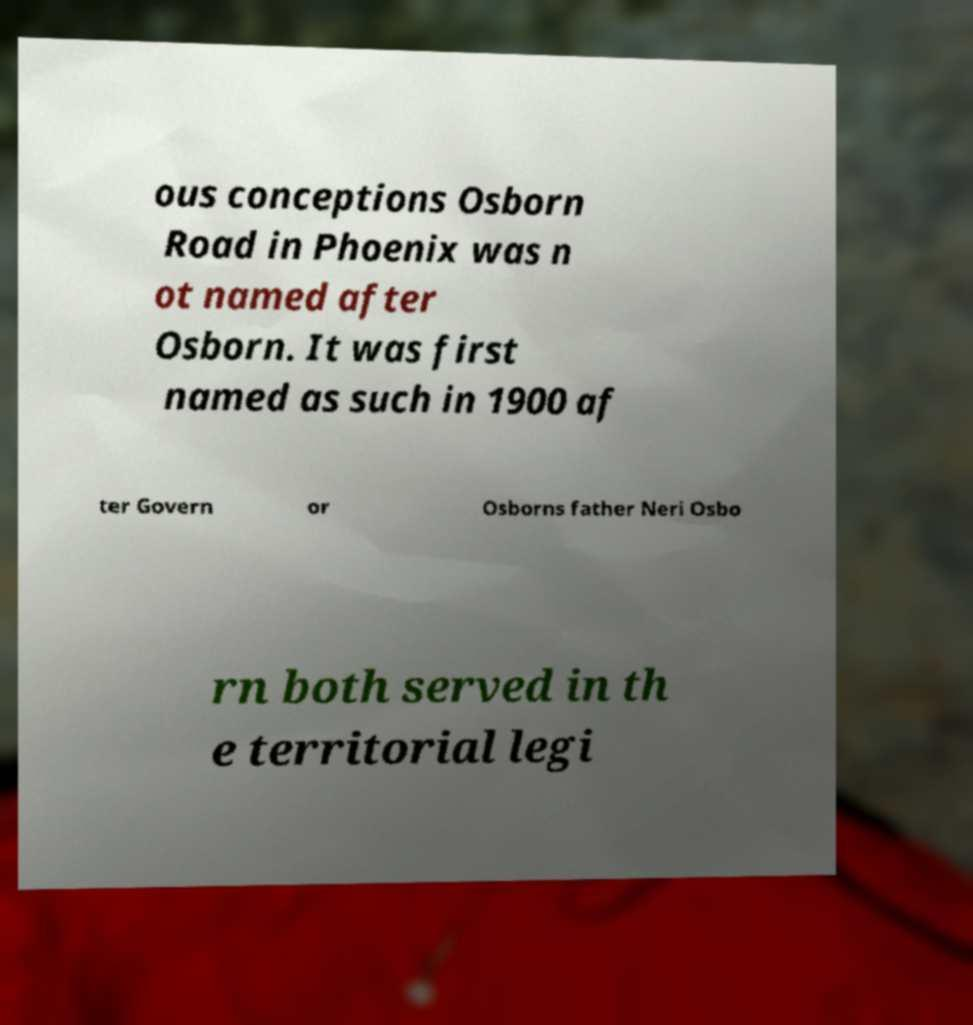What messages or text are displayed in this image? I need them in a readable, typed format. ous conceptions Osborn Road in Phoenix was n ot named after Osborn. It was first named as such in 1900 af ter Govern or Osborns father Neri Osbo rn both served in th e territorial legi 